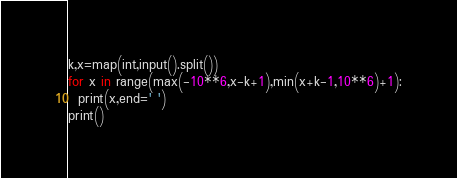Convert code to text. <code><loc_0><loc_0><loc_500><loc_500><_Python_>k,x=map(int,input().split())
for x in range(max(-10**6,x-k+1),min(x+k-1,10**6)+1):
  print(x,end=' ')
print()
</code> 